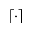<formula> <loc_0><loc_0><loc_500><loc_500>\lceil \cdot \rceil</formula> 